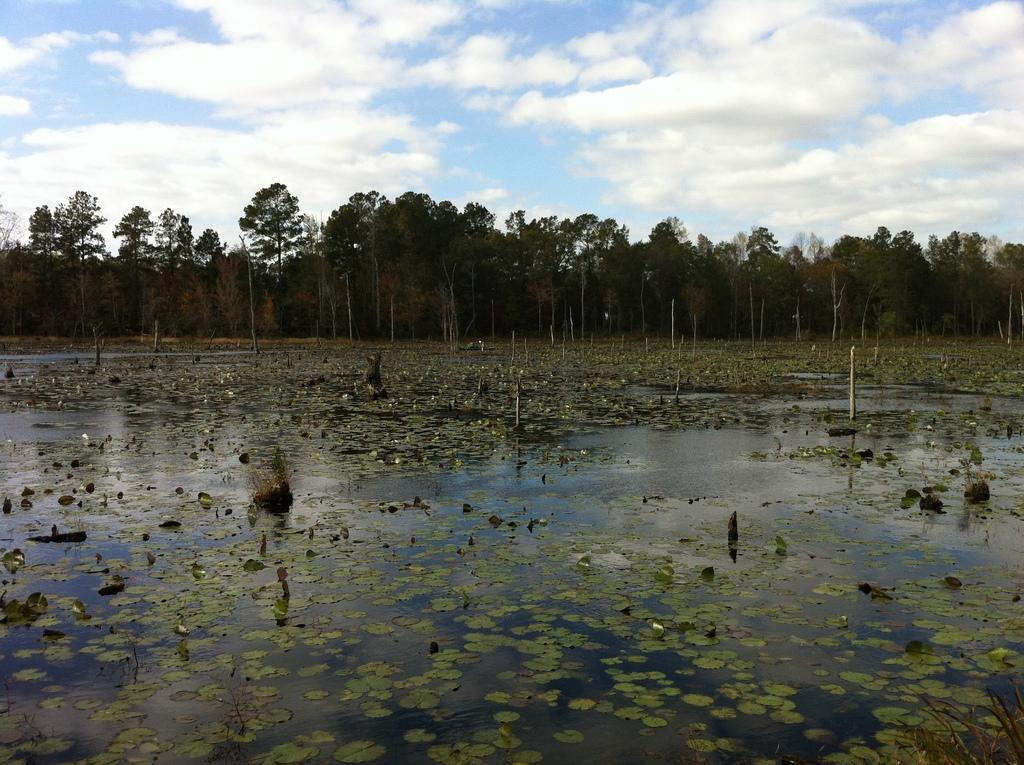What is floating on the surface of the water in the image? There are leaves on the surface of the water in the image. What can be seen in the background of the image? Trees are present in the background of the image. What is visible at the top of the image? The sky is visible at the top of the image. What can be observed in the sky? Clouds are present in the sky. What type of coal is being mined in the image? There is no coal or mining operation present in the image; it features leaves on the surface of the water, trees in the background, and clouds in the sky. What is the size of the operation in the image? There is no operation present in the image, so it is not possible to determine its size. 